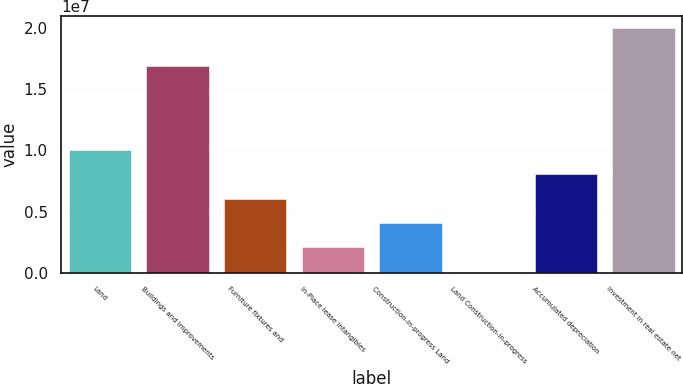<chart> <loc_0><loc_0><loc_500><loc_500><bar_chart><fcel>Land<fcel>Buildings and improvements<fcel>Furniture fixtures and<fcel>In-Place lease intangibles<fcel>Construction-in-progress Land<fcel>Land Construction-in-progress<fcel>Accumulated depreciation<fcel>Investment in real estate net<nl><fcel>1.00552e+07<fcel>1.69134e+07<fcel>6.06692e+06<fcel>2.0786e+06<fcel>4.07276e+06<fcel>84440<fcel>8.06108e+06<fcel>2.0026e+07<nl></chart> 